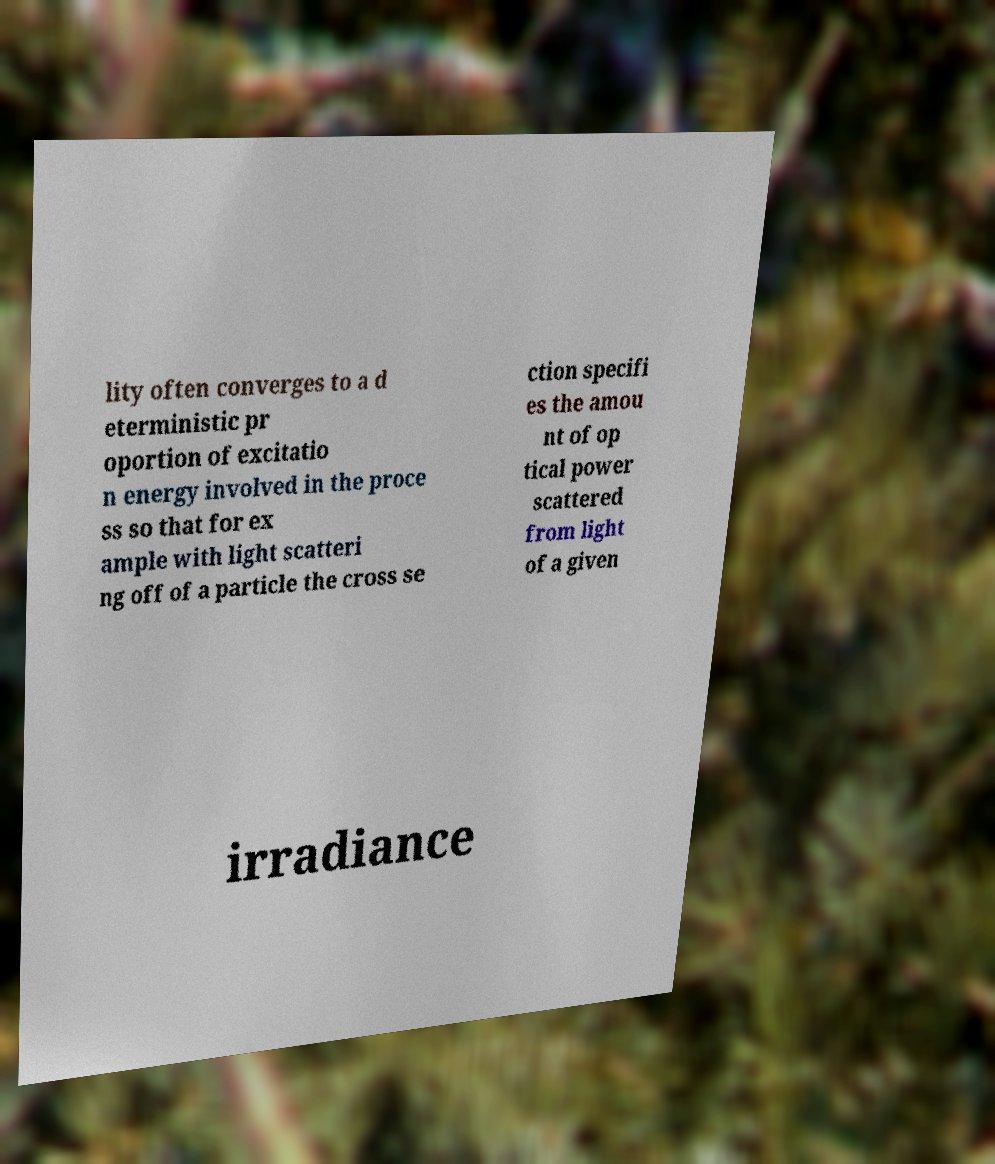Could you extract and type out the text from this image? lity often converges to a d eterministic pr oportion of excitatio n energy involved in the proce ss so that for ex ample with light scatteri ng off of a particle the cross se ction specifi es the amou nt of op tical power scattered from light of a given irradiance 